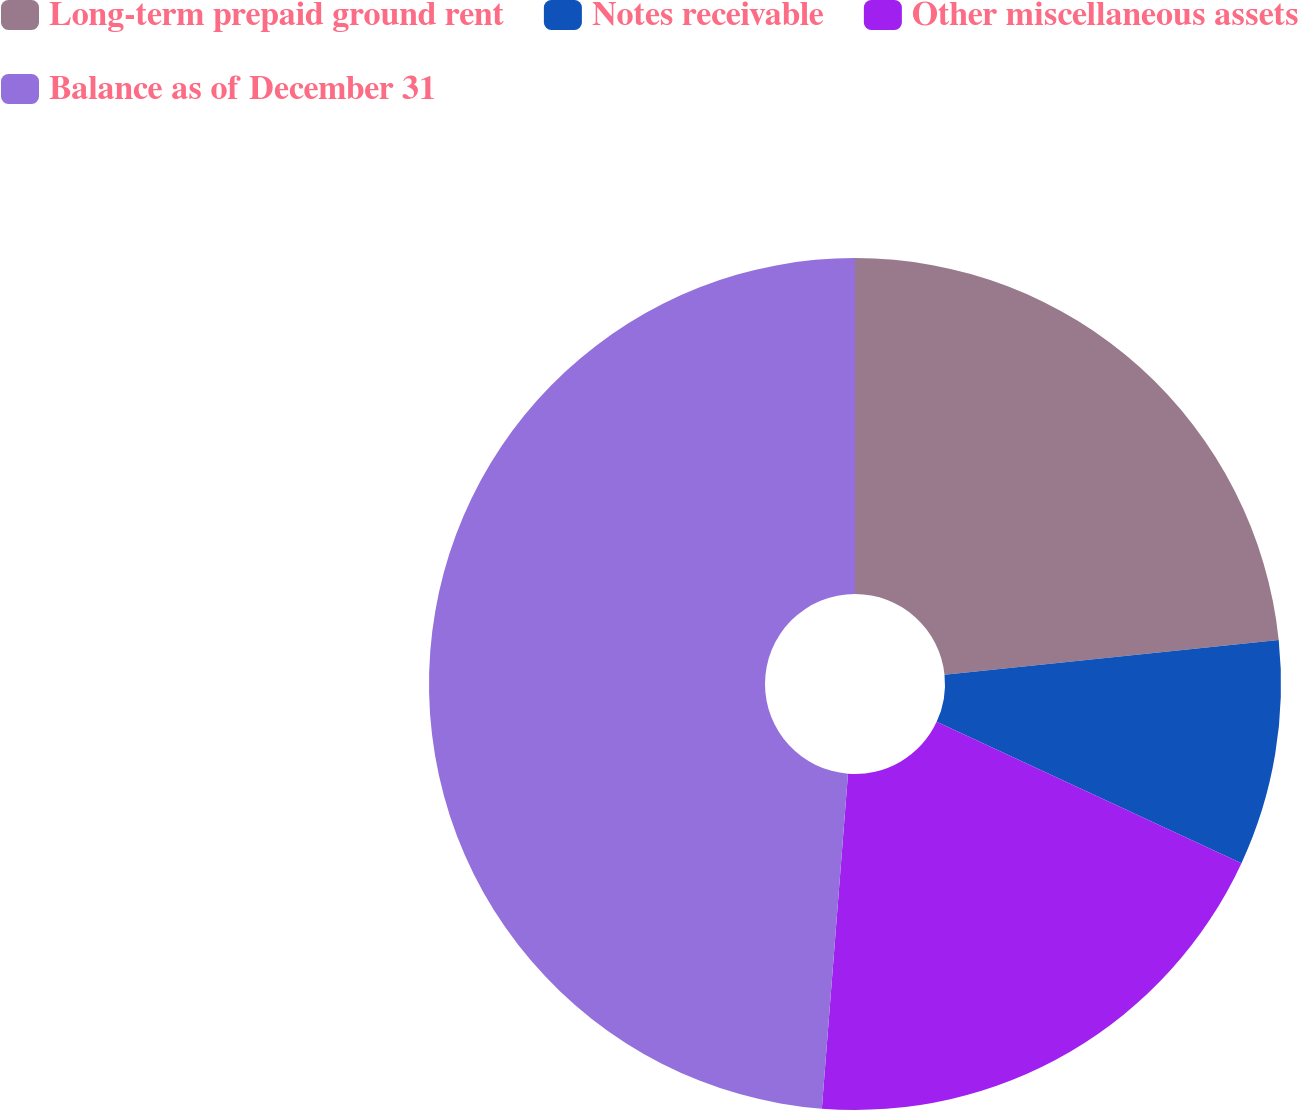Convert chart to OTSL. <chart><loc_0><loc_0><loc_500><loc_500><pie_chart><fcel>Long-term prepaid ground rent<fcel>Notes receivable<fcel>Other miscellaneous assets<fcel>Balance as of December 31<nl><fcel>23.35%<fcel>8.56%<fcel>19.33%<fcel>48.76%<nl></chart> 